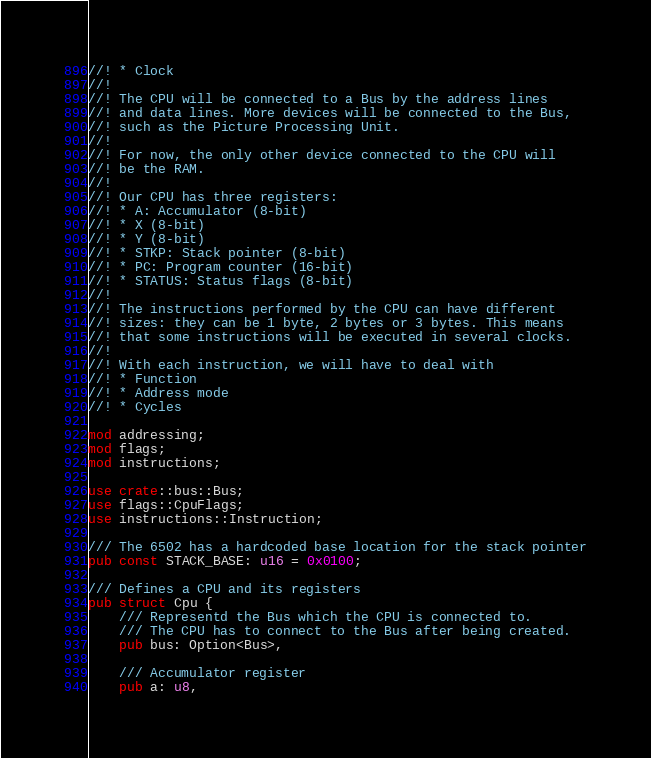Convert code to text. <code><loc_0><loc_0><loc_500><loc_500><_Rust_>//! * Clock
//!
//! The CPU will be connected to a Bus by the address lines
//! and data lines. More devices will be connected to the Bus,
//! such as the Picture Processing Unit.
//!
//! For now, the only other device connected to the CPU will
//! be the RAM.
//!
//! Our CPU has three registers:
//! * A: Accumulator (8-bit)
//! * X (8-bit)
//! * Y (8-bit)
//! * STKP: Stack pointer (8-bit)
//! * PC: Program counter (16-bit)
//! * STATUS: Status flags (8-bit)
//!
//! The instructions performed by the CPU can have different
//! sizes: they can be 1 byte, 2 bytes or 3 bytes. This means
//! that some instructions will be executed in several clocks.
//!
//! With each instruction, we will have to deal with
//! * Function
//! * Address mode
//! * Cycles

mod addressing;
mod flags;
mod instructions;

use crate::bus::Bus;
use flags::CpuFlags;
use instructions::Instruction;

/// The 6502 has a hardcoded base location for the stack pointer
pub const STACK_BASE: u16 = 0x0100;

/// Defines a CPU and its registers
pub struct Cpu {
    /// Representd the Bus which the CPU is connected to.
    /// The CPU has to connect to the Bus after being created.
    pub bus: Option<Bus>,

    /// Accumulator register
    pub a: u8,</code> 